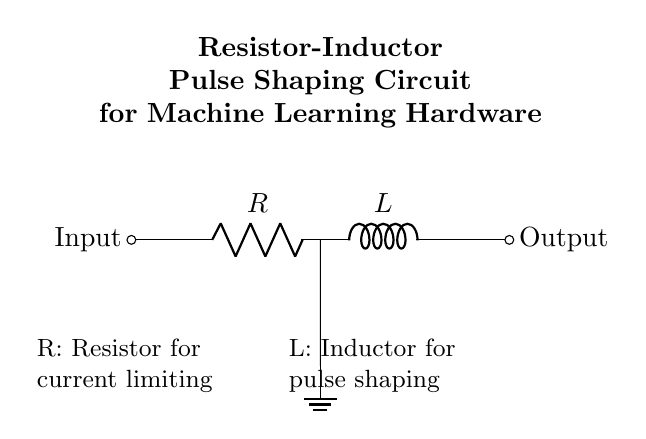What is the first component in the circuit? The first component in the circuit is a resistor, which is identified as R in the diagram. It is located right after the input signal.
Answer: Resistor What does the inductor do in this circuit? The inductor's primary function in this circuit is pulse shaping, which involves modifying the waveform of the input signal for effective processing in machine learning hardware.
Answer: Pulse shaping How many components are in the circuit? The circuit contains two components: one resistor and one inductor. Each component is distinctly labeled in the diagram.
Answer: Two What is the function of the resistor in this circuit? The resistor's function is to limit the current flowing through the circuit, which is crucial for protecting the components and ensuring proper operation.
Answer: Current limiting What type of circuit is shown? The circuit is a Resistor-Inductor circuit, specifically designed for pulse shaping in signal processing applications.
Answer: Resistor-Inductor What happens to the output signal? The output signal will be shaped based on the characteristics of the resistor and inductor, which control how quickly the signal can rise or fall, affecting its overall waveform.
Answer: Shaped How does the ground affect the circuit? The ground serves as a reference point for the voltage levels in the circuit, providing a common return path for current and ensuring stable operation across components.
Answer: Reference point 